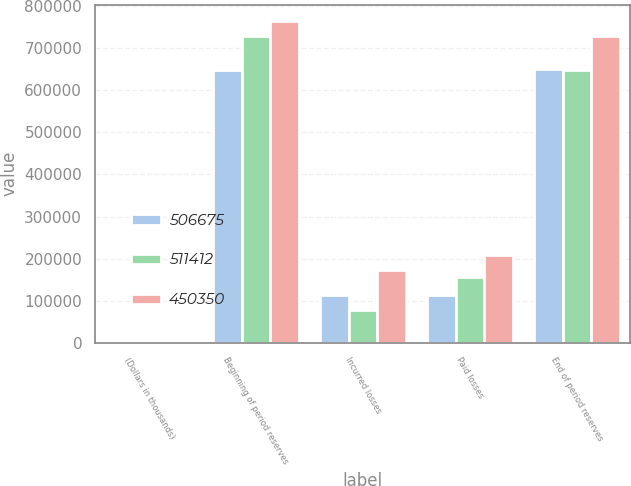Convert chart to OTSL. <chart><loc_0><loc_0><loc_500><loc_500><stacked_bar_chart><ecel><fcel>(Dollars in thousands)<fcel>Beginning of period reserves<fcel>Incurred losses<fcel>Paid losses<fcel>End of period reserves<nl><fcel>506675<fcel>2006<fcel>649460<fcel>113400<fcel>112726<fcel>650134<nl><fcel>511412<fcel>2005<fcel>728325<fcel>77050<fcel>155915<fcel>649460<nl><fcel>450350<fcel>2004<fcel>765257<fcel>171729<fcel>208661<fcel>728325<nl></chart> 